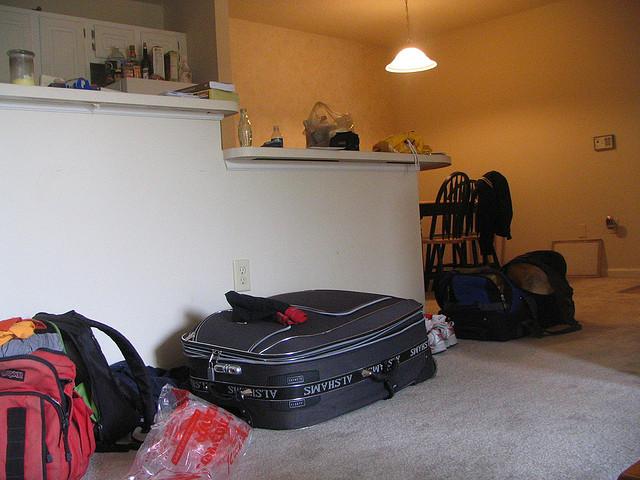How many luggages are visible?
Concise answer only. 4. What is luggage used for?
Short answer required. Traveling. Is the luggage packed?
Answer briefly. Yes. What color is the spotted luggage?
Concise answer only. Black. 